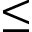<formula> <loc_0><loc_0><loc_500><loc_500>\leq</formula> 